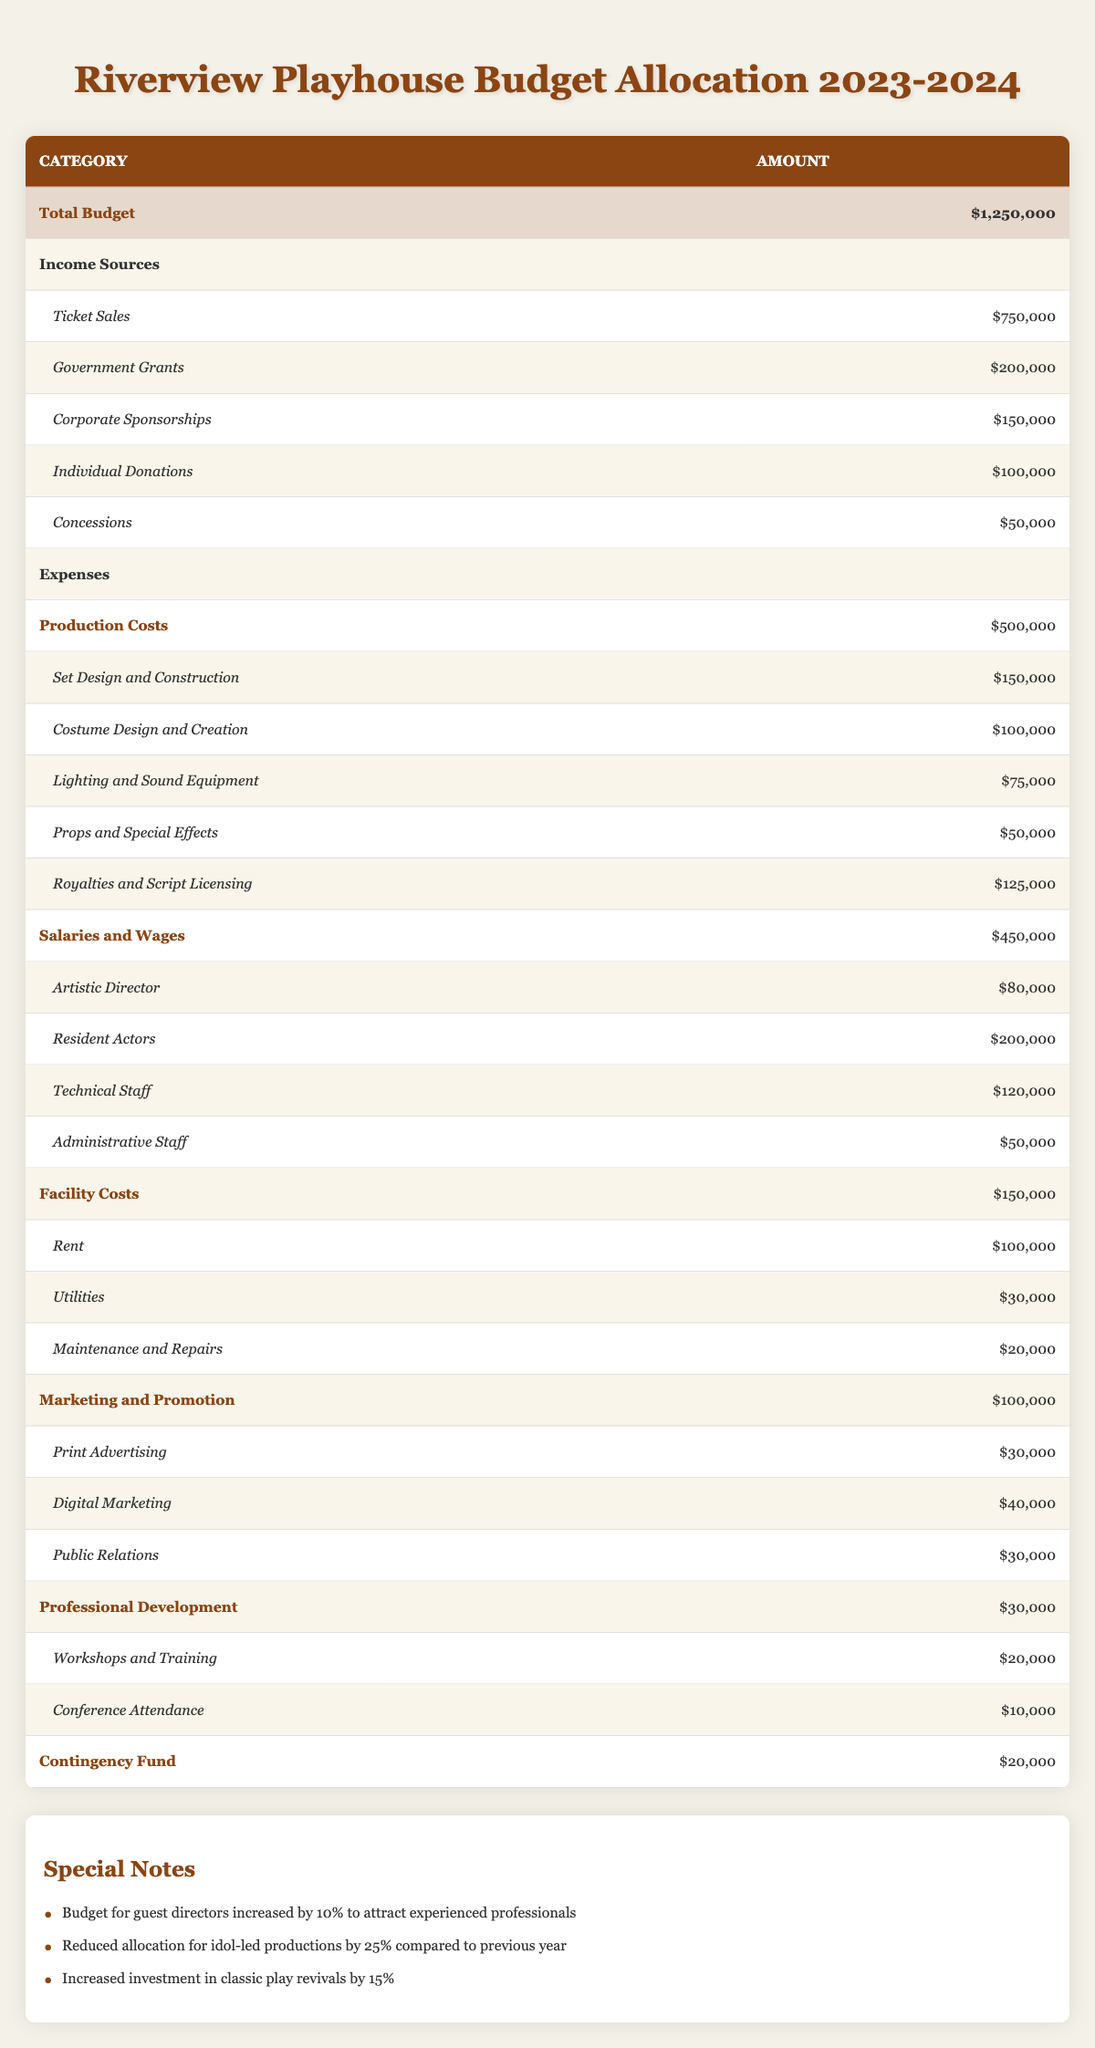What is the total budget for Riverview Playhouse for the fiscal year 2023-2024? The total budget is listed directly in the table under "Total Budget," which shows an amount of $1,250,000.
Answer: $1,250,000 What is the amount allocated for individual donations? The table lists individual donations in the income sources section, showing an allocation of $100,000.
Answer: $100,000 How much is being spent on salaries and wages compared to production costs? Salaries and wages amount to $450,000, while production costs are $500,000. To find the difference, calculate $500,000 - $450,000, resulting in $50,000.
Answer: $50,000 Is the funding for idol-led productions increasing this year? The special notes state that the allocation for idol-led productions has been reduced by 25% compared to the previous year, indicating that it is not increasing.
Answer: No What percentage of the total budget is generated from ticket sales? To find the percentage from ticket sales, divide ticket sales ($750,000) by the total budget ($1,250,000) and multiply by 100. This results in ($750,000 / $1,250,000) * 100 = 60%.
Answer: 60% What is the total amount spent on marketing and promotion? The amount allocated for marketing and promotion is listed as $100,000 in the expenses section of the table.
Answer: $100,000 How much is allocated for production costs' subcategory "Set Design and Construction"? This subcategory is listed under production costs, showing an allocation of $150,000.
Answer: $150,000 What is the combined total of contingency fund and professional development expenses? The contingency fund amounts to $20,000, and professional development costs $30,000. The combined total is $20,000 + $30,000 = $50,000.
Answer: $50,000 How much more is spent on resident actors compared to administrative staff? The budget for resident actors is $200,000 and for administrative staff is $50,000. The difference is $200,000 - $50,000 = $150,000.
Answer: $150,000 